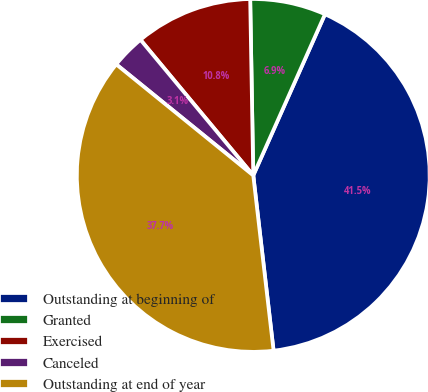<chart> <loc_0><loc_0><loc_500><loc_500><pie_chart><fcel>Outstanding at beginning of<fcel>Granted<fcel>Exercised<fcel>Canceled<fcel>Outstanding at end of year<nl><fcel>41.5%<fcel>6.94%<fcel>10.76%<fcel>3.12%<fcel>37.68%<nl></chart> 